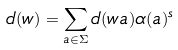Convert formula to latex. <formula><loc_0><loc_0><loc_500><loc_500>d ( w ) = \sum _ { a \in \Sigma } d ( w a ) \alpha ( a ) ^ { s }</formula> 